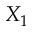<formula> <loc_0><loc_0><loc_500><loc_500>X _ { 1 }</formula> 